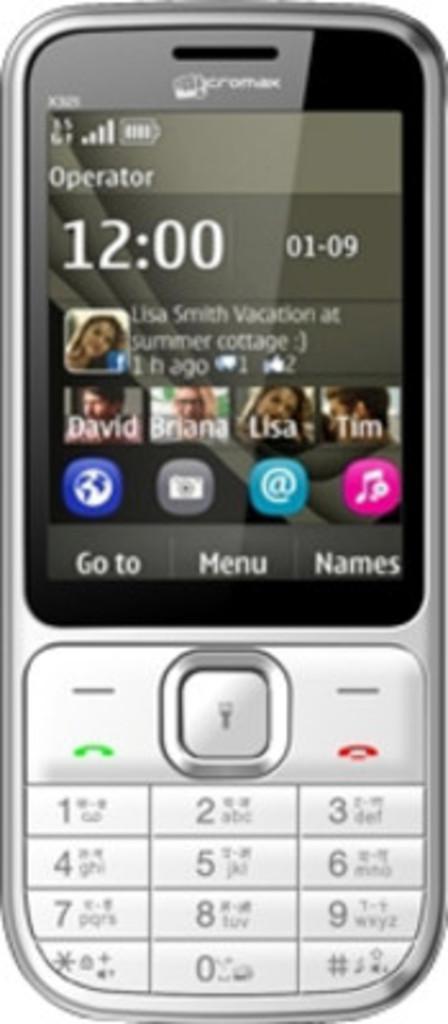What time is it on the screen?
Keep it short and to the point. 12:00. 